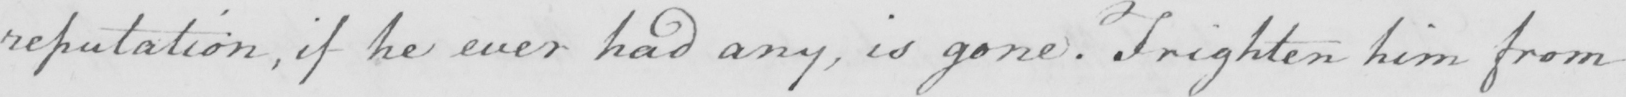Transcribe the text shown in this historical manuscript line. reputation , if he ever had any , is gone . Frighten him from 